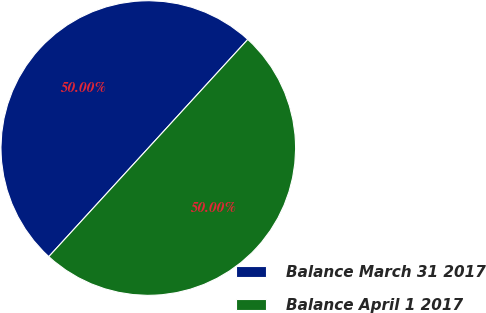<chart> <loc_0><loc_0><loc_500><loc_500><pie_chart><fcel>Balance March 31 2017<fcel>Balance April 1 2017<nl><fcel>50.0%<fcel>50.0%<nl></chart> 